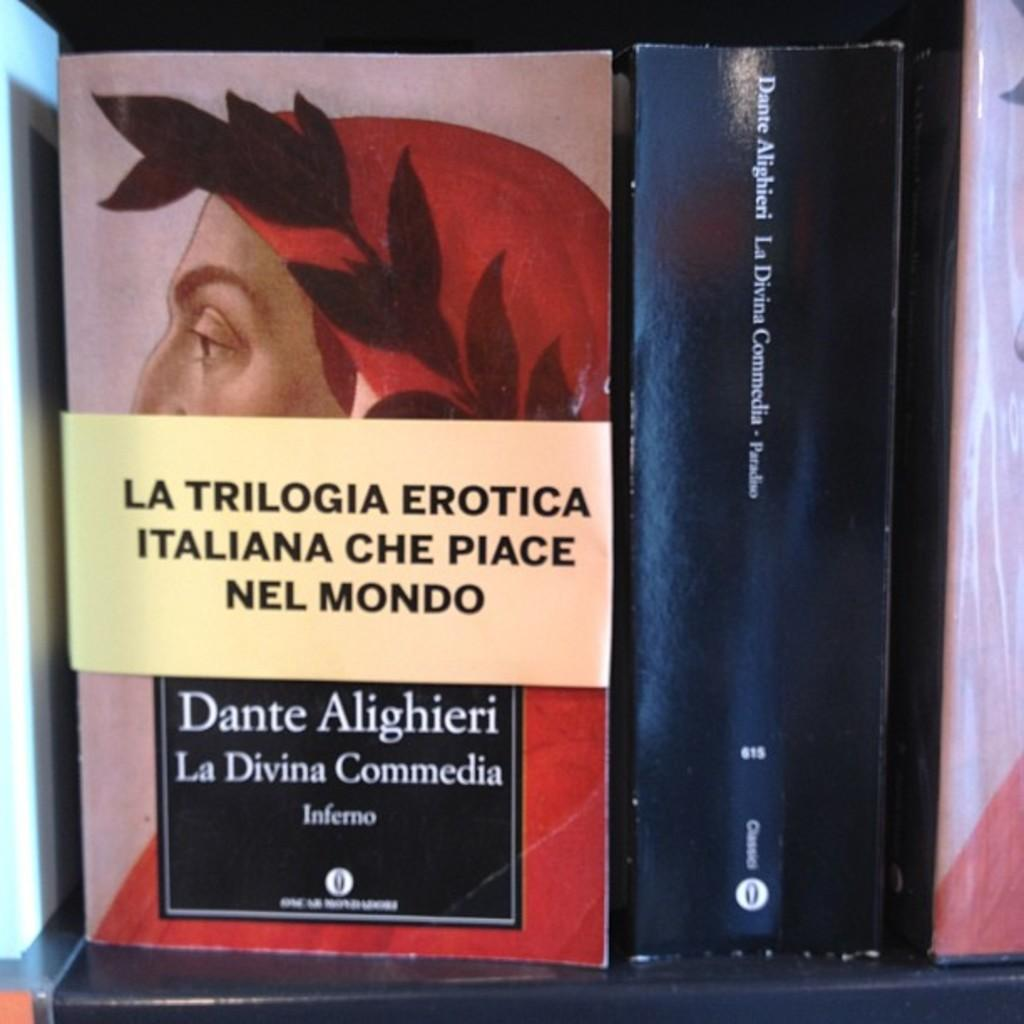What type of objects can be seen in the image? The image contains books. Can you describe the books in the image? The books are likely arranged on a shelf or table, but the specific arrangement or number of books cannot be determined from the provided facts. What might the books be used for? The books might be used for reading, studying, or reference purposes. What letter is the fireman holding in the image? There is no fireman or letter present in the image; it only contains books. 